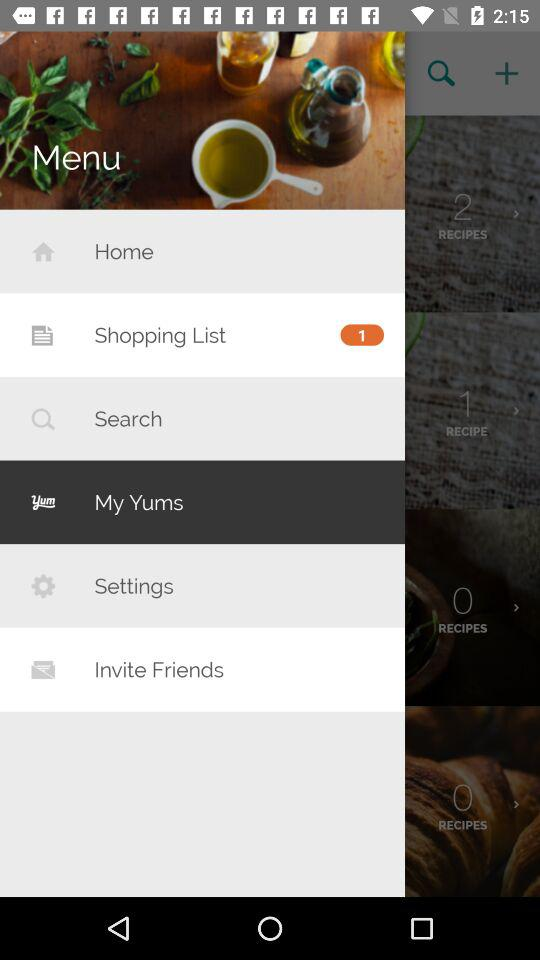How many lists are in the "Shopping List"? The "Shopping List" has only 1 list. 